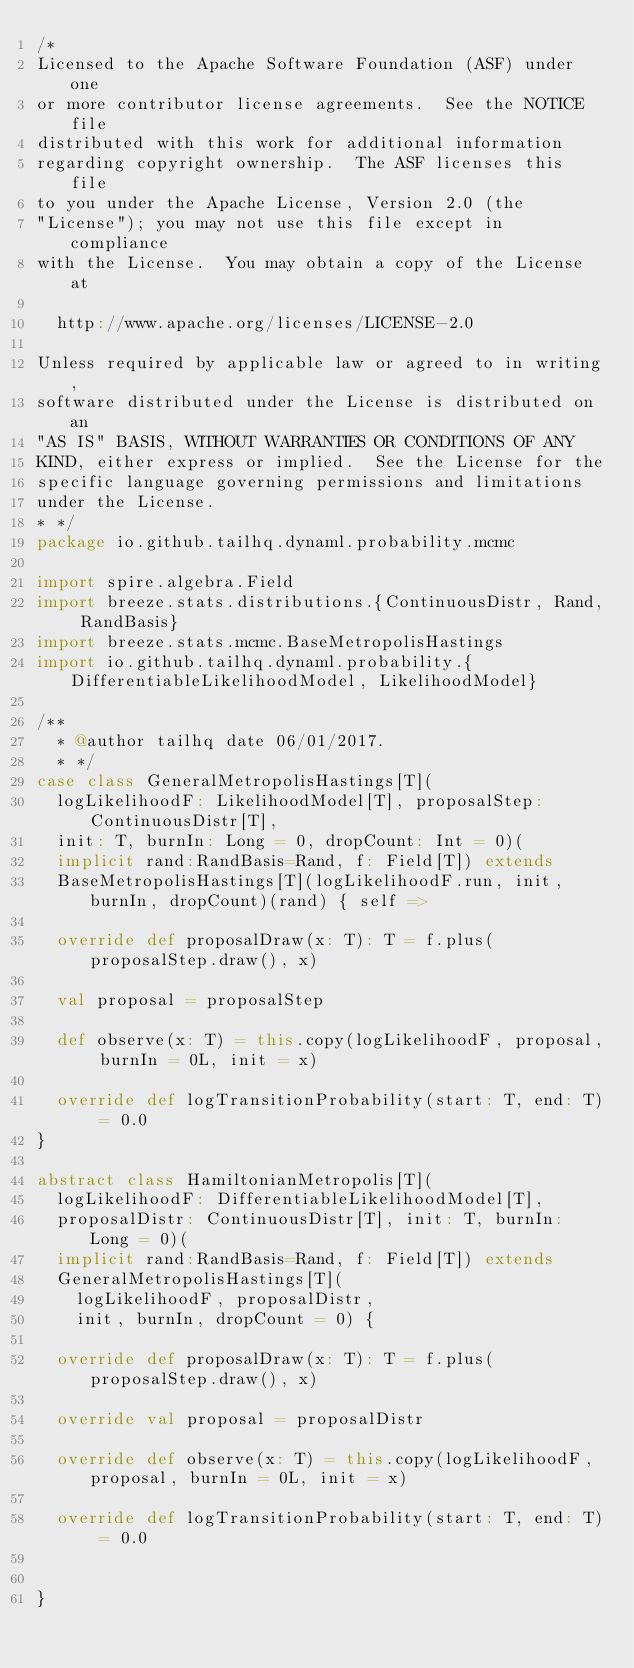Convert code to text. <code><loc_0><loc_0><loc_500><loc_500><_Scala_>/*
Licensed to the Apache Software Foundation (ASF) under one
or more contributor license agreements.  See the NOTICE file
distributed with this work for additional information
regarding copyright ownership.  The ASF licenses this file
to you under the Apache License, Version 2.0 (the
"License"); you may not use this file except in compliance
with the License.  You may obtain a copy of the License at

  http://www.apache.org/licenses/LICENSE-2.0

Unless required by applicable law or agreed to in writing,
software distributed under the License is distributed on an
"AS IS" BASIS, WITHOUT WARRANTIES OR CONDITIONS OF ANY
KIND, either express or implied.  See the License for the
specific language governing permissions and limitations
under the License.
* */
package io.github.tailhq.dynaml.probability.mcmc

import spire.algebra.Field
import breeze.stats.distributions.{ContinuousDistr, Rand, RandBasis}
import breeze.stats.mcmc.BaseMetropolisHastings
import io.github.tailhq.dynaml.probability.{DifferentiableLikelihoodModel, LikelihoodModel}

/**
  * @author tailhq date 06/01/2017.
  * */
case class GeneralMetropolisHastings[T](
  logLikelihoodF: LikelihoodModel[T], proposalStep: ContinuousDistr[T],
  init: T, burnIn: Long = 0, dropCount: Int = 0)(
  implicit rand:RandBasis=Rand, f: Field[T]) extends
  BaseMetropolisHastings[T](logLikelihoodF.run, init, burnIn, dropCount)(rand) { self =>

  override def proposalDraw(x: T): T = f.plus(proposalStep.draw(), x)

  val proposal = proposalStep

  def observe(x: T) = this.copy(logLikelihoodF, proposal, burnIn = 0L, init = x)

  override def logTransitionProbability(start: T, end: T) = 0.0
}

abstract class HamiltonianMetropolis[T](
  logLikelihoodF: DifferentiableLikelihoodModel[T],
  proposalDistr: ContinuousDistr[T], init: T, burnIn: Long = 0)(
  implicit rand:RandBasis=Rand, f: Field[T]) extends
  GeneralMetropolisHastings[T](
    logLikelihoodF, proposalDistr,
    init, burnIn, dropCount = 0) {

  override def proposalDraw(x: T): T = f.plus(proposalStep.draw(), x)

  override val proposal = proposalDistr

  override def observe(x: T) = this.copy(logLikelihoodF, proposal, burnIn = 0L, init = x)

  override def logTransitionProbability(start: T, end: T) = 0.0


}</code> 